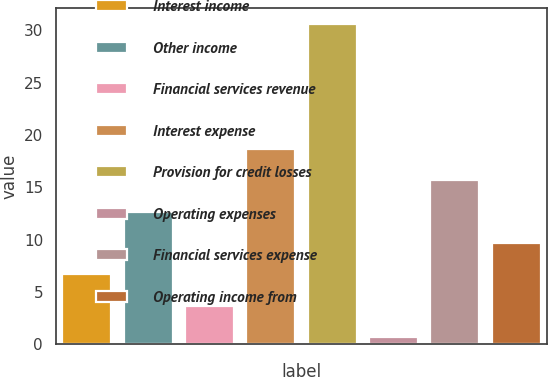Convert chart to OTSL. <chart><loc_0><loc_0><loc_500><loc_500><bar_chart><fcel>Interest income<fcel>Other income<fcel>Financial services revenue<fcel>Interest expense<fcel>Provision for credit losses<fcel>Operating expenses<fcel>Financial services expense<fcel>Operating income from<nl><fcel>6.68<fcel>12.66<fcel>3.69<fcel>18.64<fcel>30.6<fcel>0.7<fcel>15.65<fcel>9.67<nl></chart> 